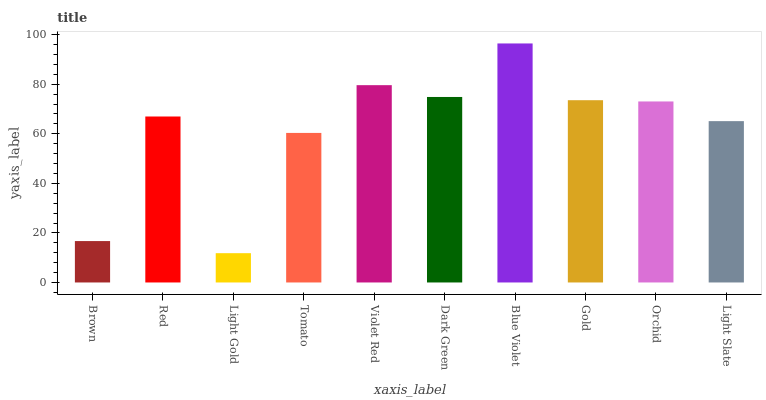Is Light Gold the minimum?
Answer yes or no. Yes. Is Blue Violet the maximum?
Answer yes or no. Yes. Is Red the minimum?
Answer yes or no. No. Is Red the maximum?
Answer yes or no. No. Is Red greater than Brown?
Answer yes or no. Yes. Is Brown less than Red?
Answer yes or no. Yes. Is Brown greater than Red?
Answer yes or no. No. Is Red less than Brown?
Answer yes or no. No. Is Orchid the high median?
Answer yes or no. Yes. Is Red the low median?
Answer yes or no. Yes. Is Brown the high median?
Answer yes or no. No. Is Blue Violet the low median?
Answer yes or no. No. 